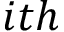<formula> <loc_0><loc_0><loc_500><loc_500>i t h</formula> 